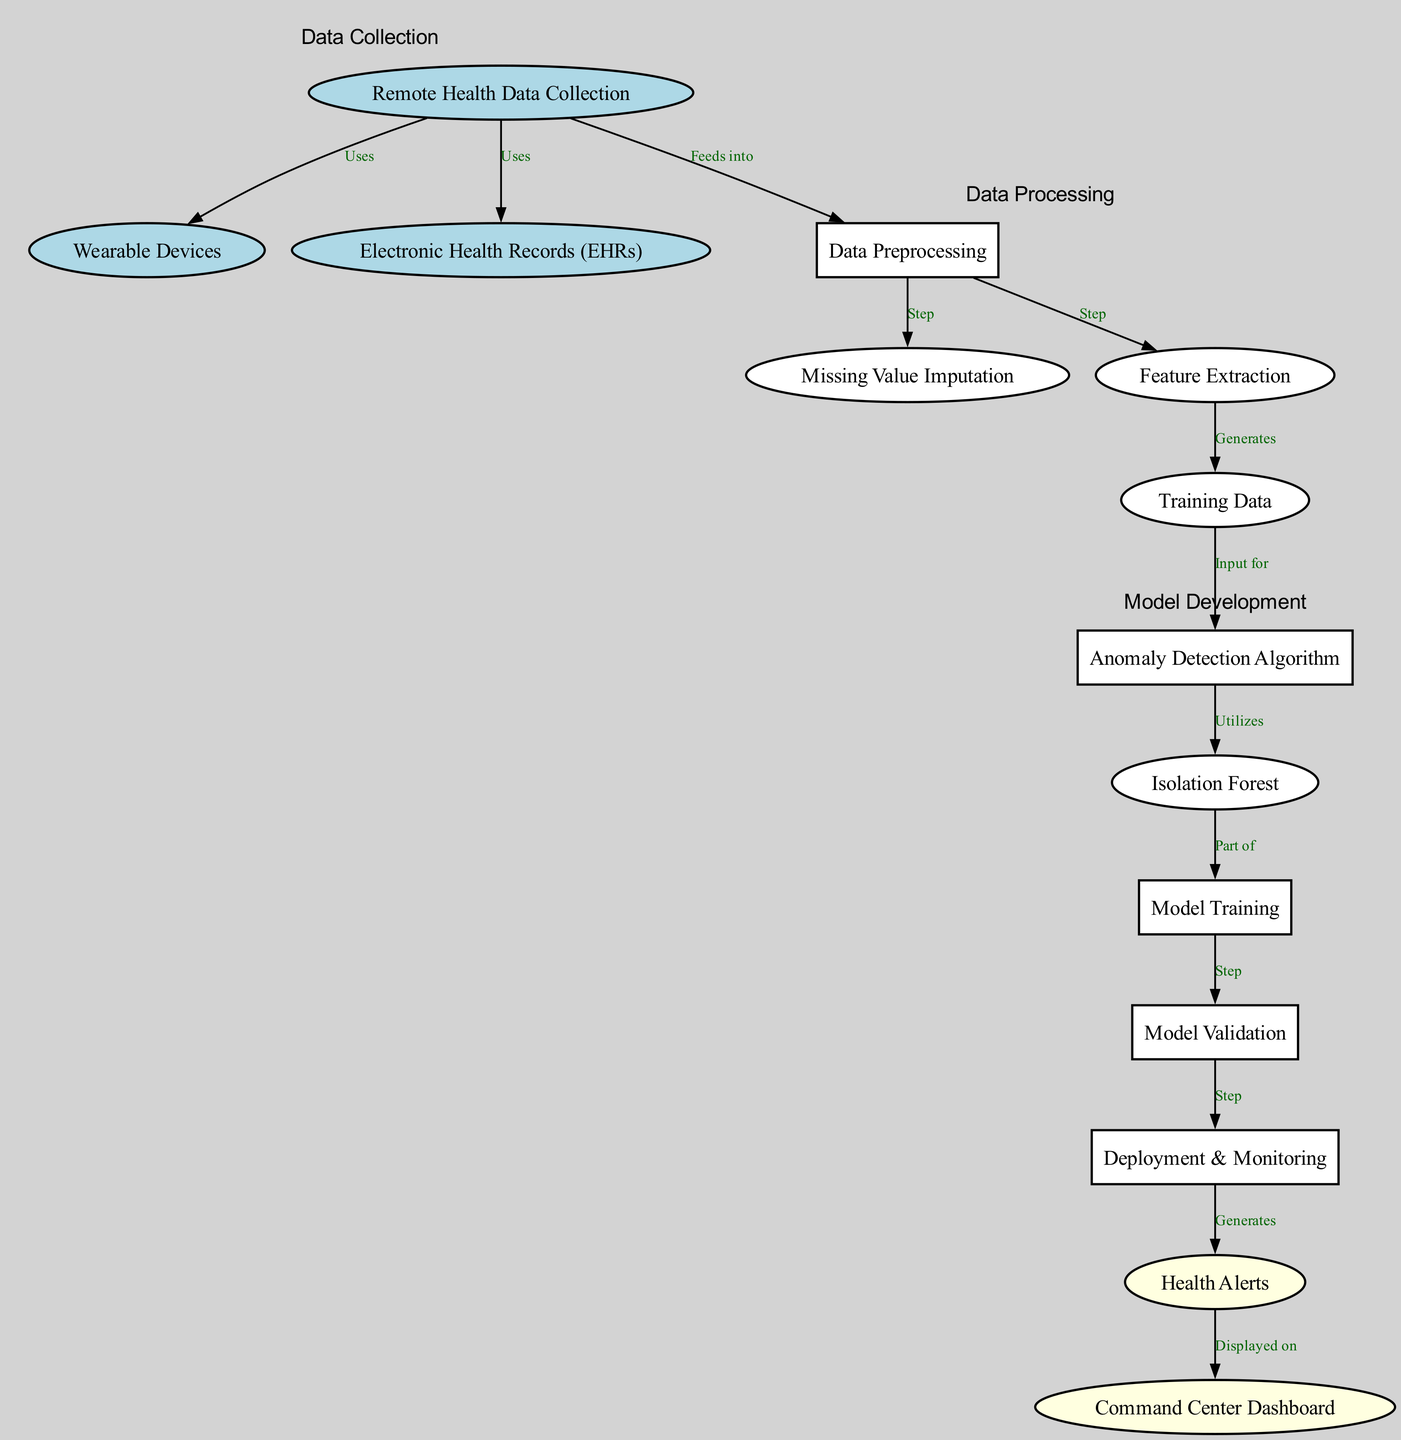What does the "Remote Health Data Collection" node feed into? The "Remote Health Data Collection" node connects to the "Data Preprocessing" node, indicating that it feeds into this process.
Answer: Data Preprocessing How many nodes are present in the diagram? By counting all the individual nodes listed in the diagram, we find there are fourteen total nodes.
Answer: Fourteen What algorithm is utilized in the anomaly detection process? The diagram indicates that the "Anomaly Detection Algorithm" node utilizes the "Isolation Forest" algorithm, as shown by the arrow pointing from the algorithm node to the Isolation Forest node.
Answer: Isolation Forest What generates "Training Data"? The "Feature Extraction" node is connected to the "Training Data" node, meaning it generates the training data necessary for subsequent processes.
Answer: Feature Extraction What is displayed on the "Command Center Dashboard"? The "Health Alerts" node is connected to the "Command Center Dashboard," indicating that it is the information displayed there.
Answer: Health Alerts What step follows model training? Following the "Model Training" step, "Model Validation" occurs as indicated by the directed edge connecting these nodes in the diagram.
Answer: Model Validation Which nodes belong to the 'Data Processing' cluster? The nodes "Data Preprocessing," "Missing Value Imputation," "Feature Extraction," and "Training Data" are all included in the 'Data Processing' cluster, as detailed in the grouping of nodes.
Answer: Data Preprocessing, Missing Value Imputation, Feature Extraction, Training Data What generates health alerts after deployment? The "Deployment & Monitoring" node generates "Health Alerts" according to the flow depicted by the edge connecting these two nodes.
Answer: Health Alerts Which step is the last in the process? The final step in the process is shown to be "Command Center Dashboard," which indicates the end of the workflow.
Answer: Command Center Dashboard 